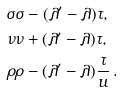Convert formula to latex. <formula><loc_0><loc_0><loc_500><loc_500>\sigma & \sigma - ( \lambda ^ { \prime } - \lambda ) \tau , \\ \nu & \nu + ( \lambda ^ { \prime } - \lambda ) \tau , \\ \rho & \rho - ( \lambda ^ { \prime } - \lambda ) \frac { \tau } { u } \, .</formula> 